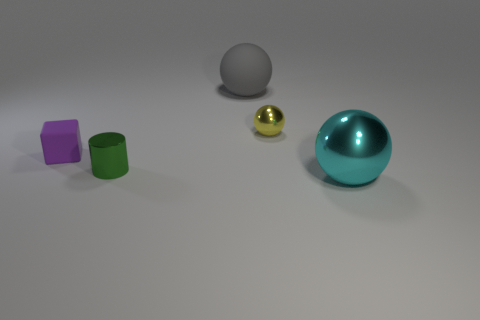Subtract all big spheres. How many spheres are left? 1 Add 1 big gray matte objects. How many objects exist? 6 Subtract all blocks. How many objects are left? 4 Add 5 cyan balls. How many cyan balls exist? 6 Subtract 0 cyan cylinders. How many objects are left? 5 Subtract all tiny green rubber balls. Subtract all small metal cylinders. How many objects are left? 4 Add 4 large gray things. How many large gray things are left? 5 